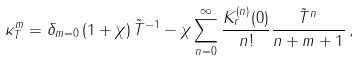<formula> <loc_0><loc_0><loc_500><loc_500>\kappa _ { T } ^ { m } = \delta _ { m = 0 } \, ( 1 + \chi ) \, \tilde { T } ^ { - 1 } - \chi \sum _ { n = 0 } ^ { \infty } \frac { K ^ { ( n ) } _ { r } ( 0 ) } { n ! } \frac { \tilde { T } ^ { n } } { n + m + 1 } \, ,</formula> 